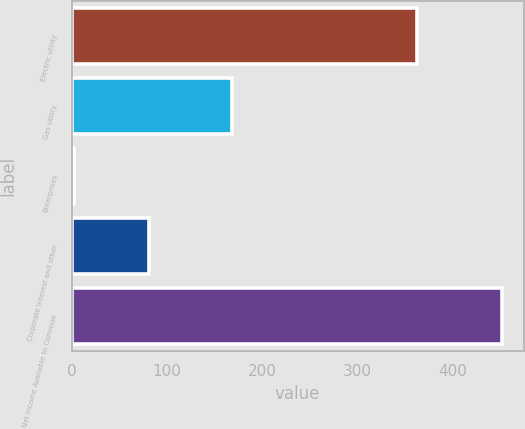<chart> <loc_0><loc_0><loc_500><loc_500><bar_chart><fcel>Electric utility<fcel>Gas utility<fcel>Enterprises<fcel>Corporate interest and other<fcel>Net Income Available to Common<nl><fcel>363<fcel>168<fcel>2<fcel>81<fcel>452<nl></chart> 